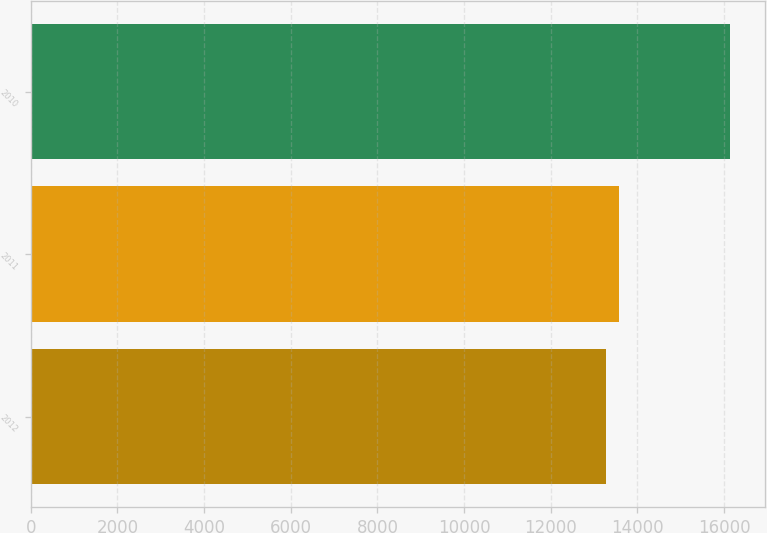Convert chart to OTSL. <chart><loc_0><loc_0><loc_500><loc_500><bar_chart><fcel>2012<fcel>2011<fcel>2010<nl><fcel>13284<fcel>13568.7<fcel>16131<nl></chart> 